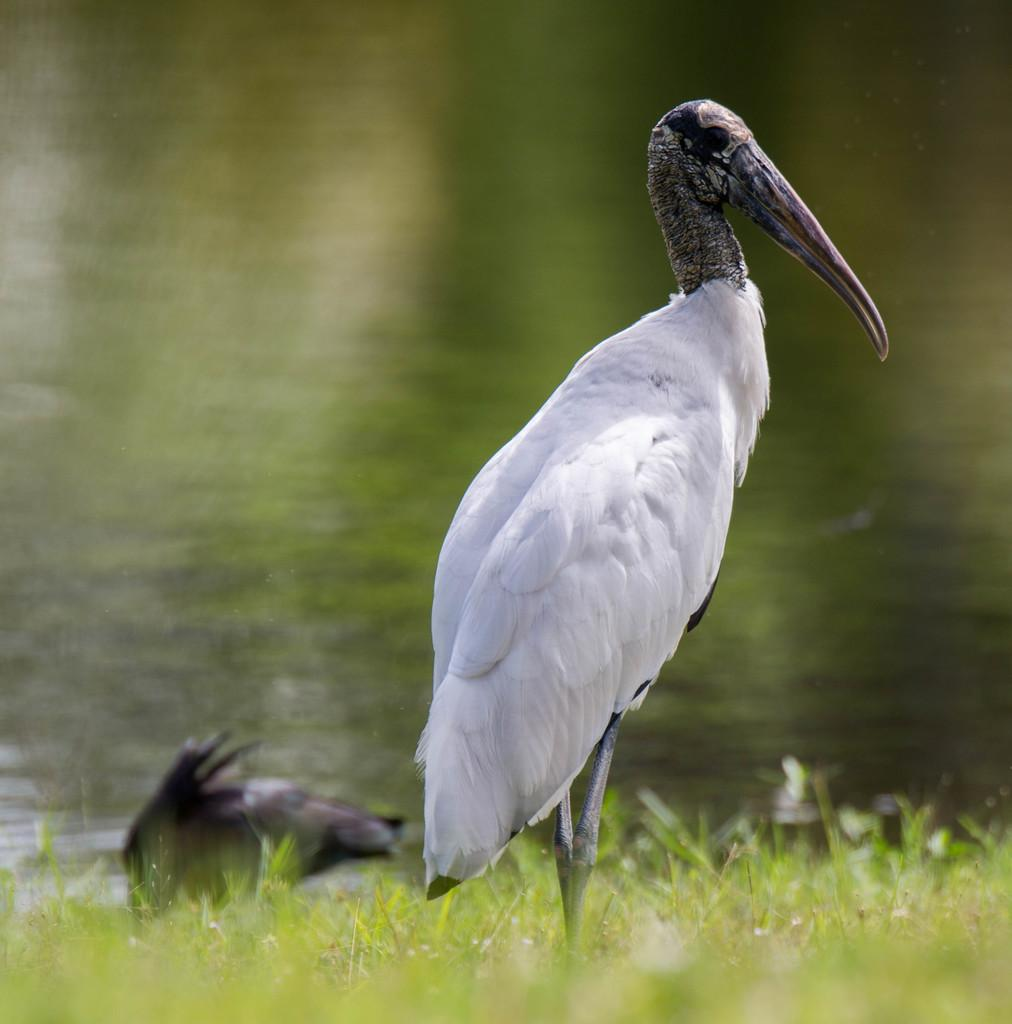What type of animal is in the image? There is a bird in the image. Where is the bird located? The bird is standing on the grass. Can you describe the background of the image? The background of the image is blurred. What type of bulb is being discussed in the meeting in the image? There is no meeting or bulb present in the image; it features a bird standing on the grass with a blurred background. 